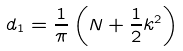Convert formula to latex. <formula><loc_0><loc_0><loc_500><loc_500>d _ { 1 } = \frac { 1 } { \pi } \left ( N + \frac { 1 } { 2 } k ^ { 2 } \right )</formula> 